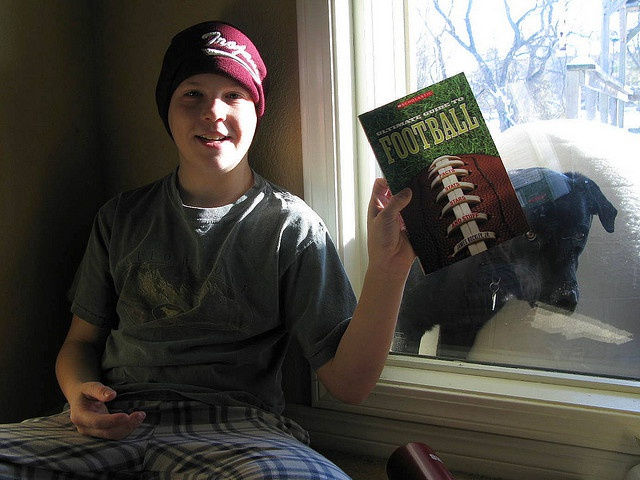Describe the objects in this image and their specific colors. I can see people in black, maroon, and gray tones, book in black, gray, maroon, and darkgreen tones, and dog in black, gray, darkblue, and blue tones in this image. 